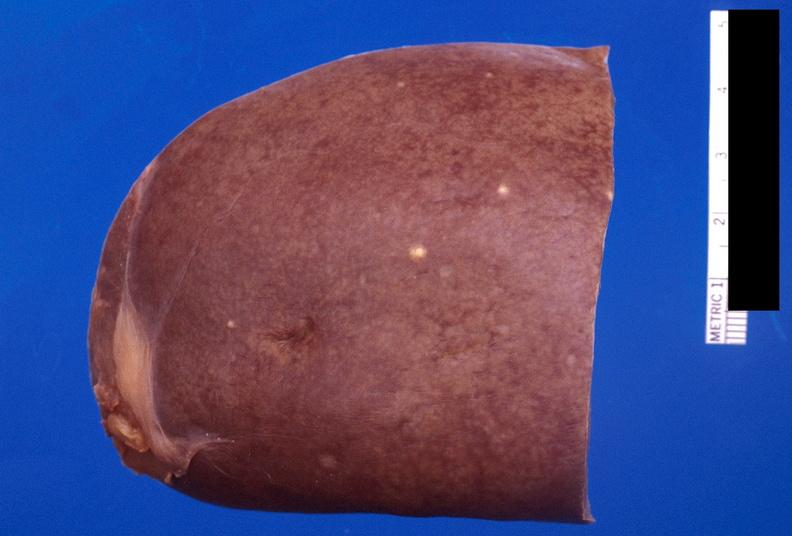where is this part in?
Answer the question using a single word or phrase. Spleen 